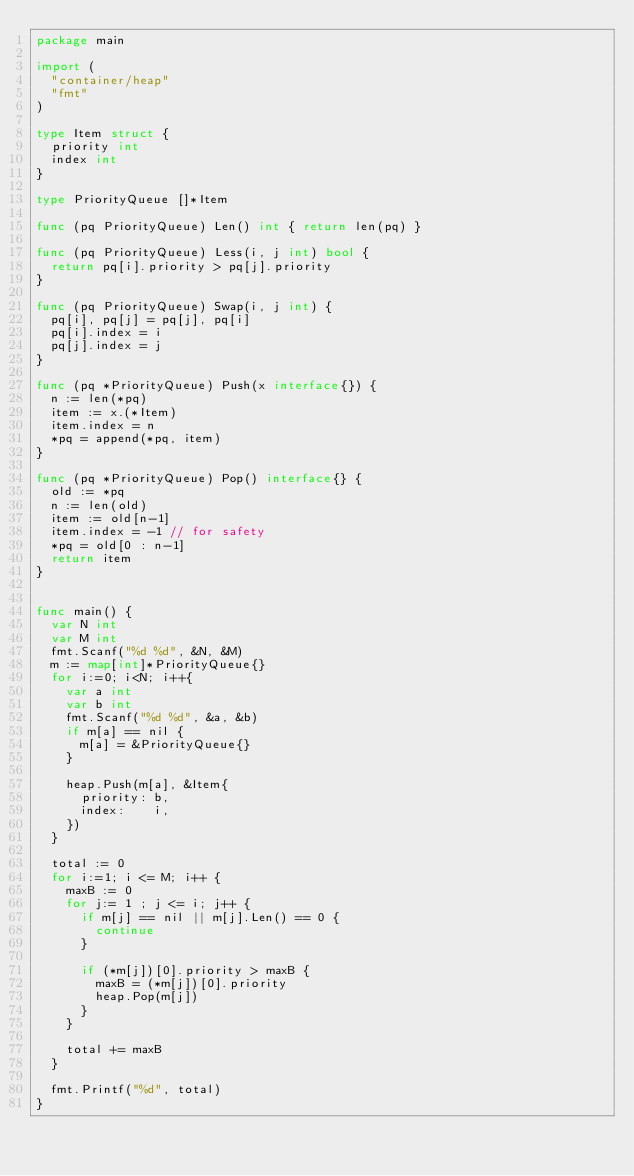Convert code to text. <code><loc_0><loc_0><loc_500><loc_500><_Go_>package main

import (
	"container/heap"
	"fmt"
)

type Item struct {
	priority int
	index int
}

type PriorityQueue []*Item

func (pq PriorityQueue) Len() int { return len(pq) }

func (pq PriorityQueue) Less(i, j int) bool {
	return pq[i].priority > pq[j].priority
}

func (pq PriorityQueue) Swap(i, j int) {
	pq[i], pq[j] = pq[j], pq[i]
	pq[i].index = i
	pq[j].index = j
}

func (pq *PriorityQueue) Push(x interface{}) {
	n := len(*pq)
	item := x.(*Item)
	item.index = n
	*pq = append(*pq, item)
}

func (pq *PriorityQueue) Pop() interface{} {
	old := *pq
	n := len(old)
	item := old[n-1]
	item.index = -1 // for safety
	*pq = old[0 : n-1]
	return item
}


func main() {
	var N int
	var M int
	fmt.Scanf("%d %d", &N, &M)
	m := map[int]*PriorityQueue{}
	for i:=0; i<N; i++{
		var a int
		var b int
		fmt.Scanf("%d %d", &a, &b)
		if m[a] == nil {
			m[a] = &PriorityQueue{}
		}

		heap.Push(m[a], &Item{
			priority: b,
			index:    i,
		})
	}

	total := 0
	for i:=1; i <= M; i++ {
		maxB := 0
		for j:= 1 ; j <= i; j++ {
			if m[j] == nil || m[j].Len() == 0 {
				continue
			}

			if (*m[j])[0].priority > maxB {
				maxB = (*m[j])[0].priority
				heap.Pop(m[j])
			}
		}

		total += maxB
	}

	fmt.Printf("%d", total)
}
</code> 